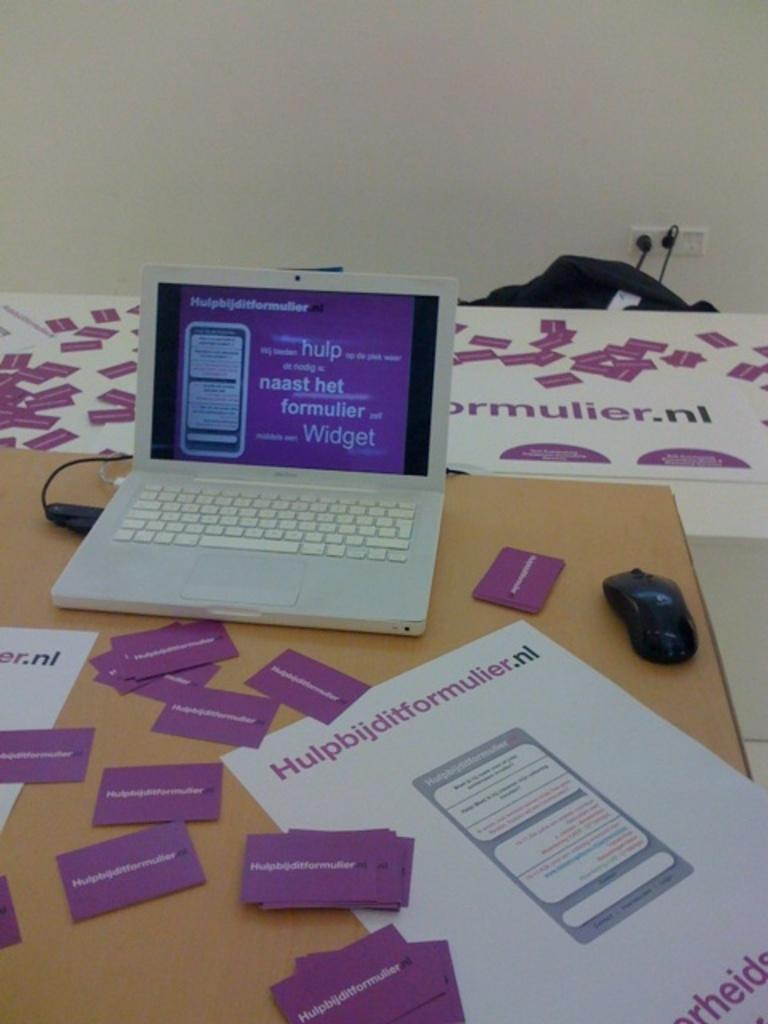<image>
Present a compact description of the photo's key features. A white laptop on a table that says ormulier.nl. 